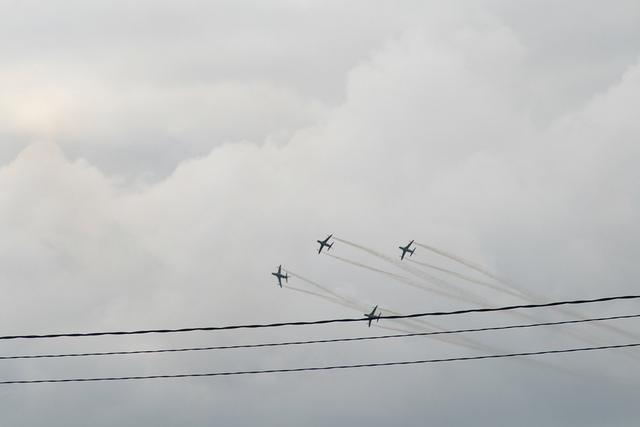Where is the sun?
Keep it brief. Behind clouds. Is this a military exercise?
Short answer required. Yes. What movie represents this photo?
Be succinct. Top gun. Is this a ski lift in the sky?
Quick response, please. No. Are the planes in danger of hitting the wires?
Concise answer only. No. How many planes are here?
Quick response, please. 4. 